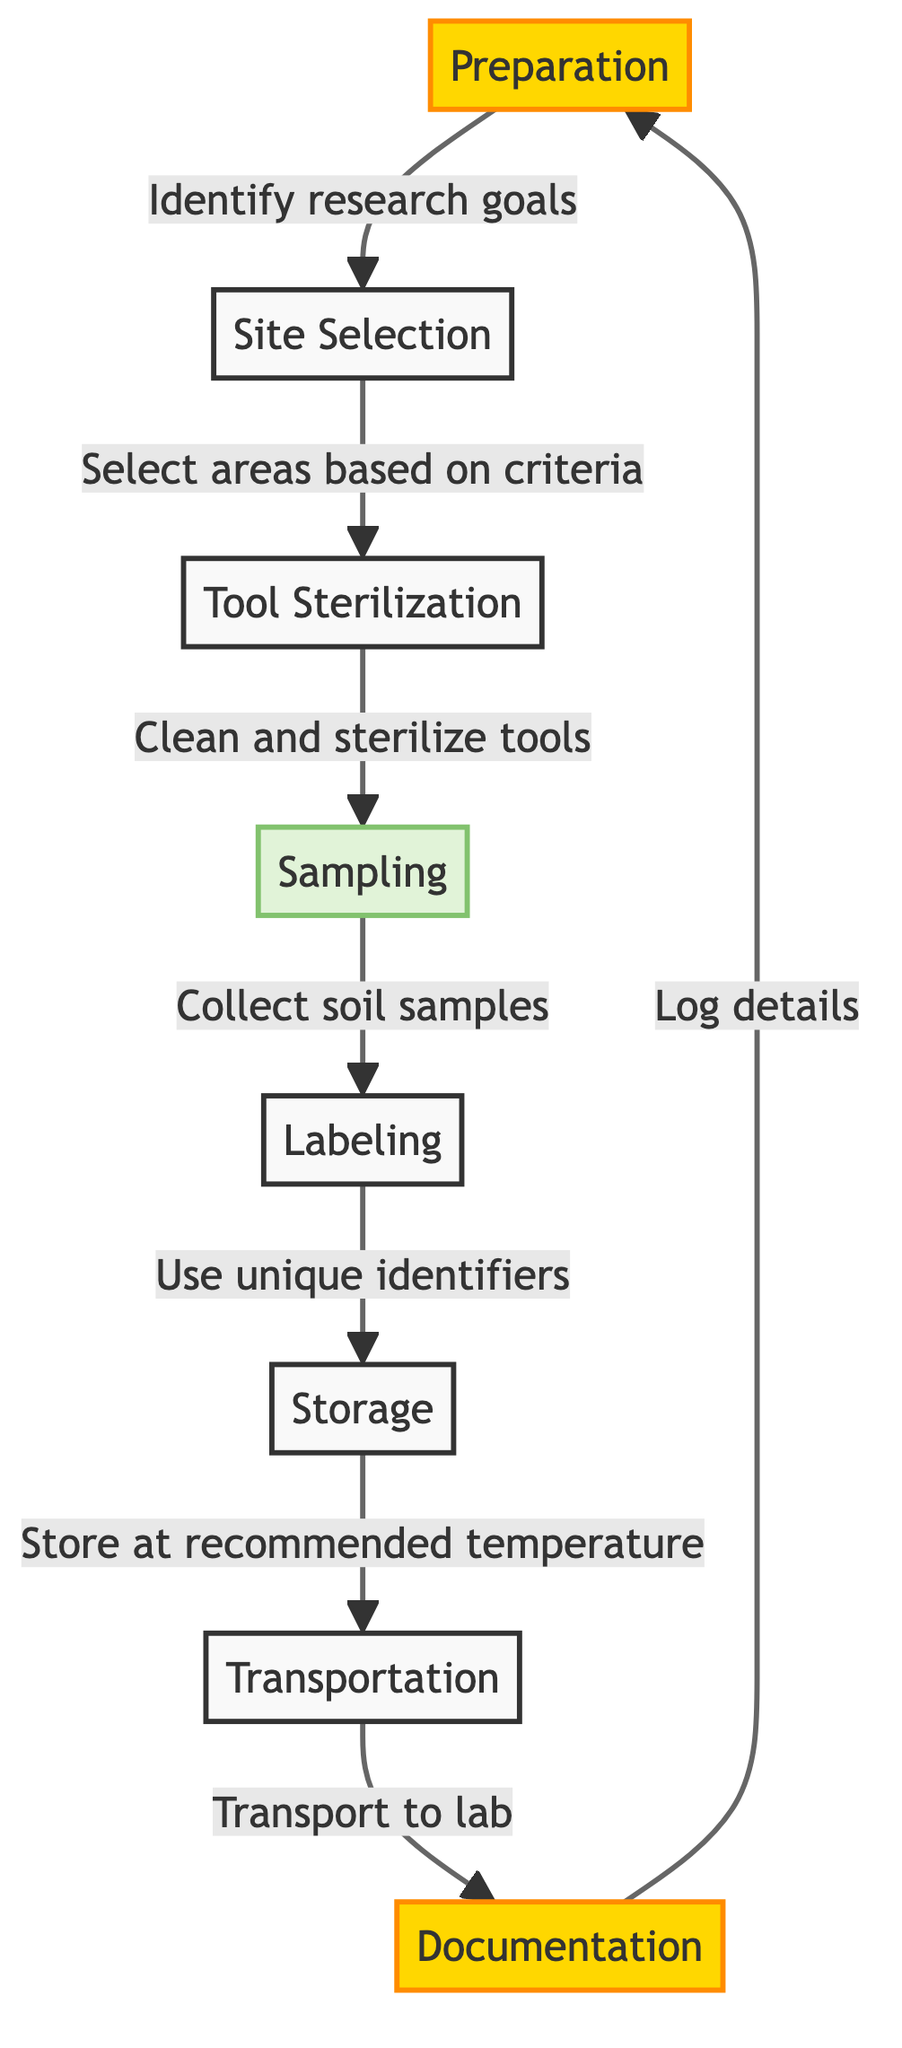What is the first step in the soil sample collection process? The diagram indicates that the first step is "Preparation," which is identified as an important node at the start of the flowchart.
Answer: Preparation How many main steps are there in the soil sample collection process? By counting the nodes provided in the diagram, there are a total of eight main steps listed, which include preparation, site selection, tool sterilization, sampling, labeling, storage, transportation, and documentation.
Answer: Eight What action is taken after soil sampling? According to the diagram, after collecting soil samples, the next action is "Labeling," where unique identifiers are used to distinguish samples.
Answer: Labeling Which step involves cleaning tools? The diagram specifies that "Tool Sterilization" is the step dedicated to cleaning and sterilizing the tools before sampling occurs.
Answer: Tool Sterilization Which steps are categorized as important nodes? The diagram identifies "Preparation" and "Documentation" as important nodes, highlighting their significance in the soil sample collection process.
Answer: Preparation, Documentation What is the last step in the soil sample collection process? The final step in the diagram is "Documentation," which indicates logging the details of the sample collection and storage after transportation to the lab.
Answer: Documentation Which step follows the site selection step? From the diagram flow, after "Site Selection," the next step is "Tool Sterilization," indicating the necessary preparation before collecting samples.
Answer: Tool Sterilization What is required during the storage of soil samples? The diagram indicates that soil samples must be "Stored at recommended temperature," which is a requirement to maintain their integrity for research purposes.
Answer: Recommended temperature In how many stages does the sample collection process conclude? The diagram concludes the sample collection process after the final stage of "Documentation," meaning it wraps up in one concluding stage after transportation and logging.
Answer: One 